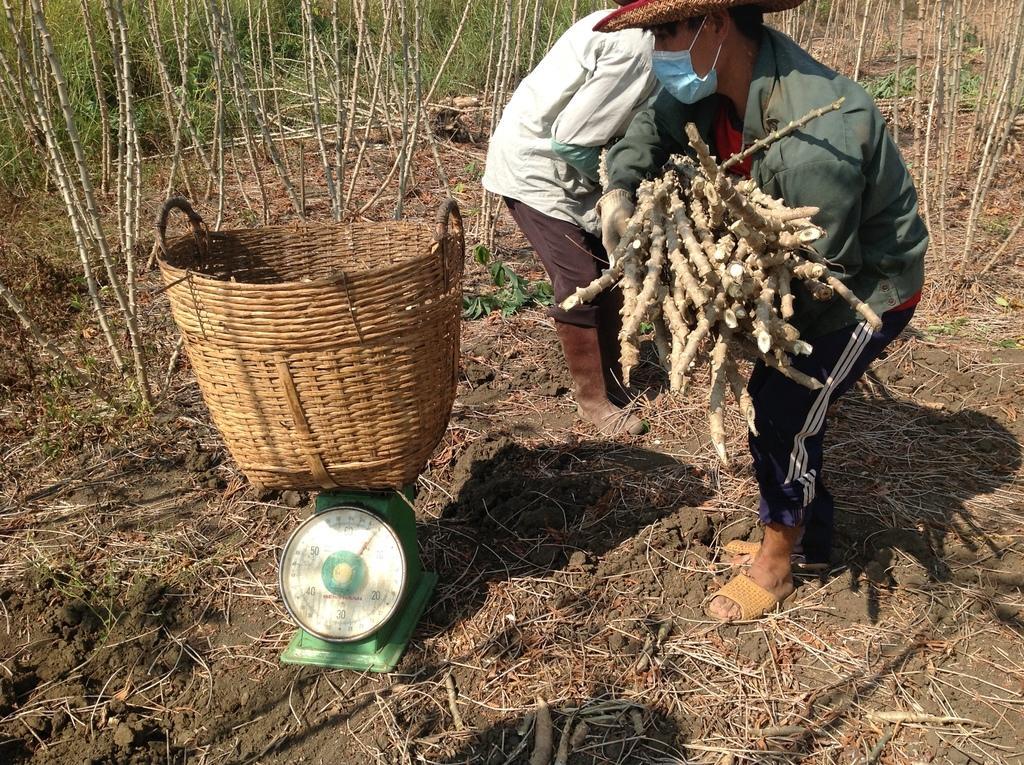Describe this image in one or two sentences. This picture shows couple of a men holding bunch of sticks and we see a basket on the weighing machine and we see plants and a man wore a hat and man wore a mask on the face. 